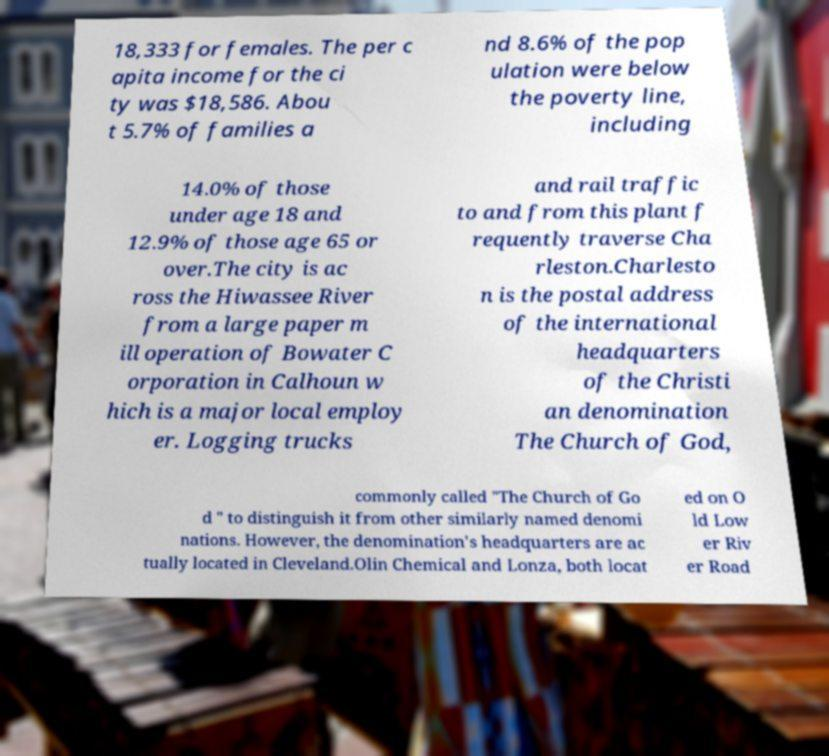Can you accurately transcribe the text from the provided image for me? 18,333 for females. The per c apita income for the ci ty was $18,586. Abou t 5.7% of families a nd 8.6% of the pop ulation were below the poverty line, including 14.0% of those under age 18 and 12.9% of those age 65 or over.The city is ac ross the Hiwassee River from a large paper m ill operation of Bowater C orporation in Calhoun w hich is a major local employ er. Logging trucks and rail traffic to and from this plant f requently traverse Cha rleston.Charlesto n is the postal address of the international headquarters of the Christi an denomination The Church of God, commonly called "The Church of Go d " to distinguish it from other similarly named denomi nations. However, the denomination's headquarters are ac tually located in Cleveland.Olin Chemical and Lonza, both locat ed on O ld Low er Riv er Road 